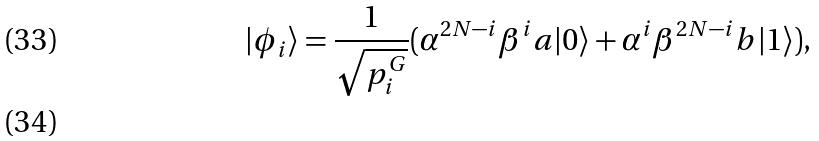<formula> <loc_0><loc_0><loc_500><loc_500>| \phi _ { i } \rangle = \frac { 1 } { \sqrt { p ^ { G } _ { i } } } ( \alpha ^ { 2 N - i } \beta ^ { i } a | 0 \rangle + \alpha ^ { i } \beta ^ { 2 N - i } b | 1 \rangle ) , \\</formula> 